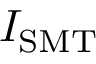Convert formula to latex. <formula><loc_0><loc_0><loc_500><loc_500>I _ { S M T }</formula> 